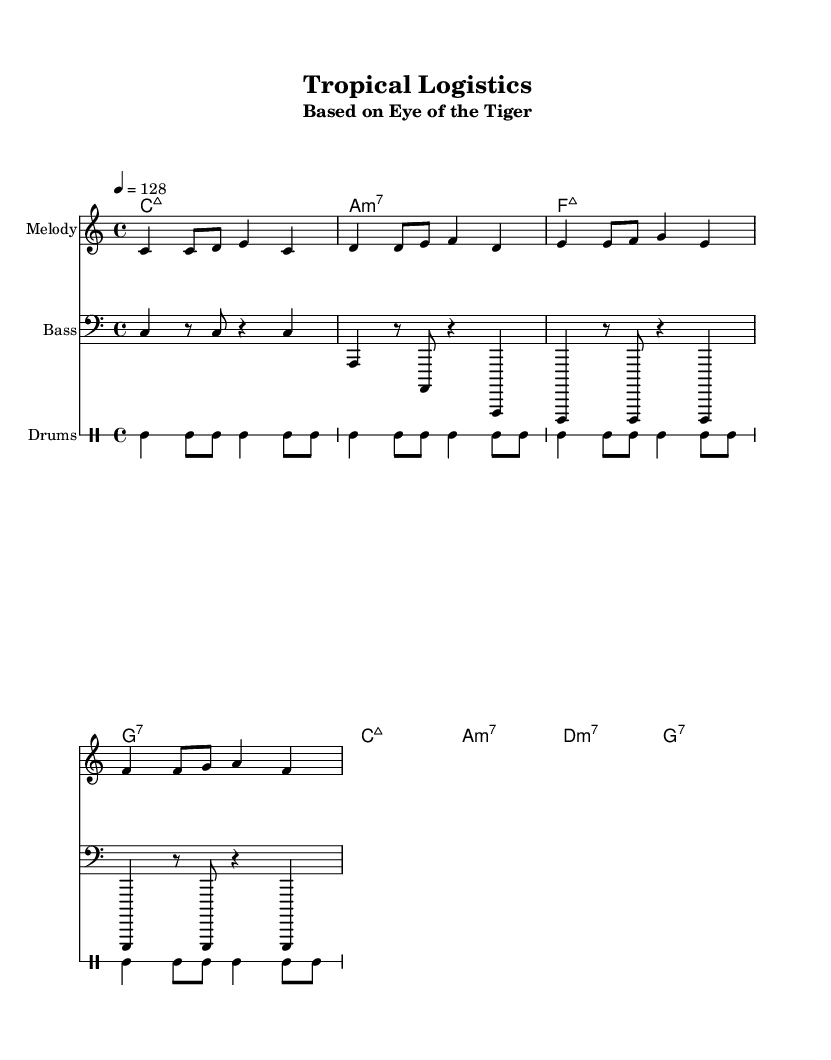What is the key signature of this music? The key signature is C major, which has no sharps or flats.
Answer: C major What is the time signature of this piece? The time signature is indicated as 4/4, meaning there are four beats in a measure.
Answer: 4/4 What is the tempo marking in this composition? The tempo marking is given as quarter note equals 128 beats per minute, indicating the speed of the music.
Answer: 128 How many measures are present in the melody? By counting the distinct phrases separated by vertical lines (bars), there are a total of 4 measures in the melody section.
Answer: 4 What instrument is indicated for the melody part? The instrument for the melody part is specified as "steel drums," which signifies the type of sound expected in the performance.
Answer: Steel drums Which chord follows the A minor 7th chord? The chord progression indicates that the next chord after A minor 7th is D minor 7th, based on the sequence provided in the harmonies.
Answer: D minor 7th What type of musical style is represented by this piece? This piece is a Tropical house remix, which combines elements of house music with tropical influences, suitable for a lively atmosphere.
Answer: Tropical house 